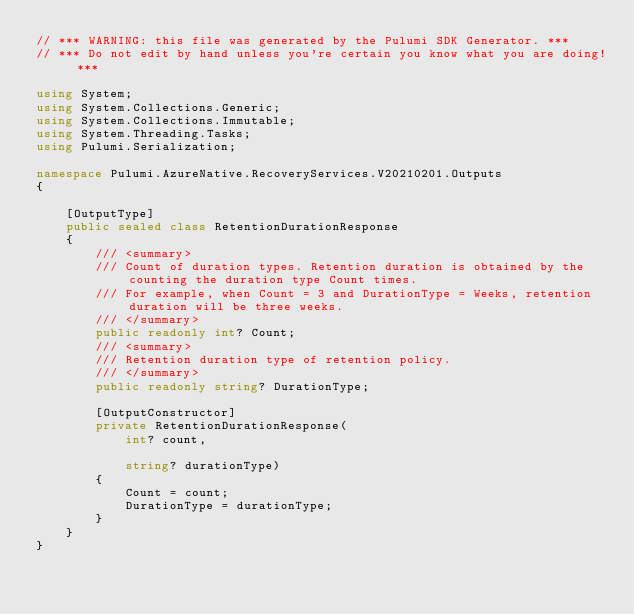Convert code to text. <code><loc_0><loc_0><loc_500><loc_500><_C#_>// *** WARNING: this file was generated by the Pulumi SDK Generator. ***
// *** Do not edit by hand unless you're certain you know what you are doing! ***

using System;
using System.Collections.Generic;
using System.Collections.Immutable;
using System.Threading.Tasks;
using Pulumi.Serialization;

namespace Pulumi.AzureNative.RecoveryServices.V20210201.Outputs
{

    [OutputType]
    public sealed class RetentionDurationResponse
    {
        /// <summary>
        /// Count of duration types. Retention duration is obtained by the counting the duration type Count times.
        /// For example, when Count = 3 and DurationType = Weeks, retention duration will be three weeks.
        /// </summary>
        public readonly int? Count;
        /// <summary>
        /// Retention duration type of retention policy.
        /// </summary>
        public readonly string? DurationType;

        [OutputConstructor]
        private RetentionDurationResponse(
            int? count,

            string? durationType)
        {
            Count = count;
            DurationType = durationType;
        }
    }
}
</code> 